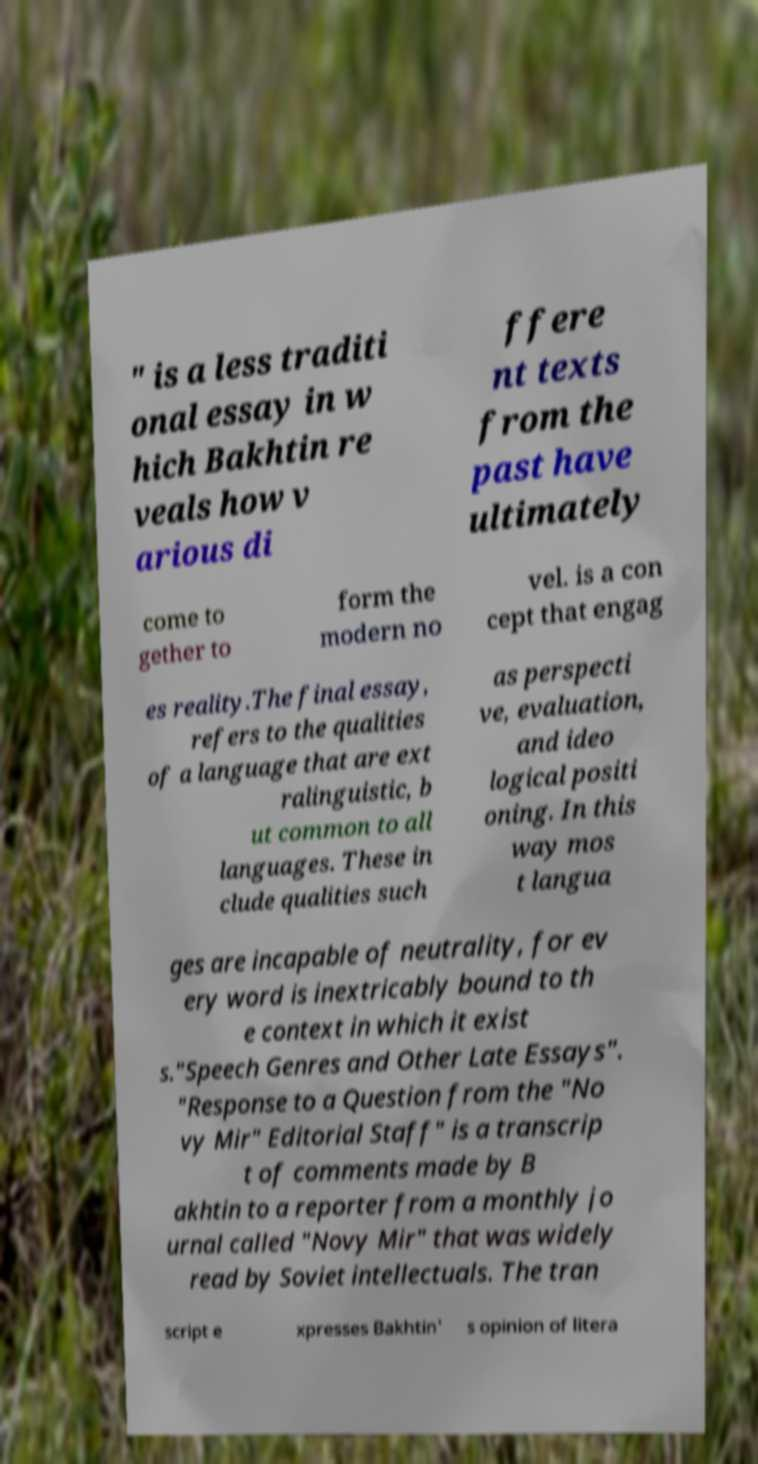I need the written content from this picture converted into text. Can you do that? " is a less traditi onal essay in w hich Bakhtin re veals how v arious di ffere nt texts from the past have ultimately come to gether to form the modern no vel. is a con cept that engag es reality.The final essay, refers to the qualities of a language that are ext ralinguistic, b ut common to all languages. These in clude qualities such as perspecti ve, evaluation, and ideo logical positi oning. In this way mos t langua ges are incapable of neutrality, for ev ery word is inextricably bound to th e context in which it exist s."Speech Genres and Other Late Essays". "Response to a Question from the "No vy Mir" Editorial Staff" is a transcrip t of comments made by B akhtin to a reporter from a monthly jo urnal called "Novy Mir" that was widely read by Soviet intellectuals. The tran script e xpresses Bakhtin' s opinion of litera 